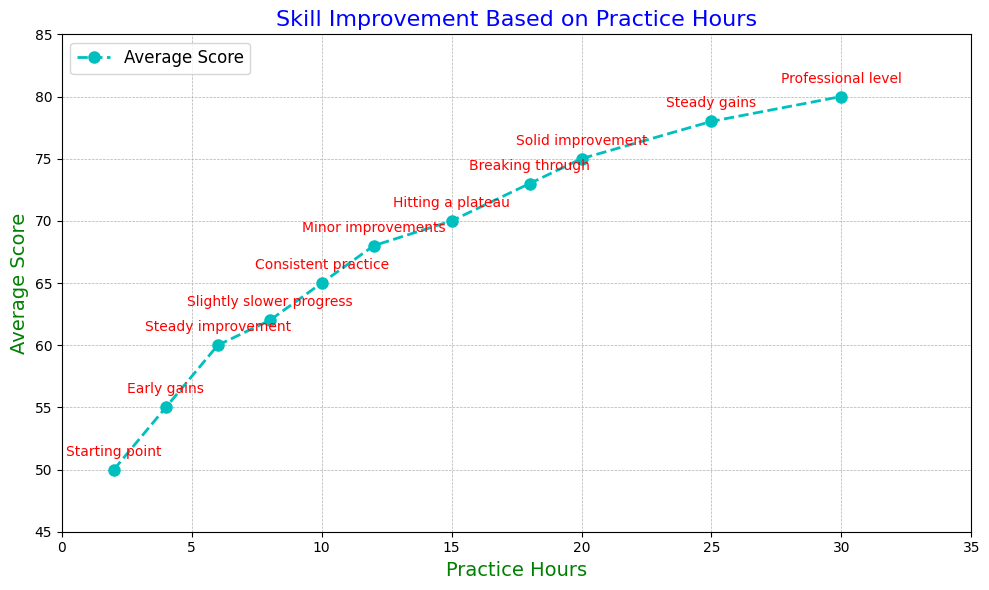What is the starting average score when the practice hours are 2? According to the annotation at the practice hour of 2, the average score is labeled as "Starting point" and the score is marked as 50.
Answer: 50 How many hours of practice does it take to reach the "Professional level"? The annotation "Professional level" is reached at 30 practice hours, as indicated by the label on the chart.
Answer: 30 Compare the average score at 8 practice hours to the score at 12 practice hours. Which is higher? From the plot, the average score at 8 hours is 62, and at 12 hours, it is 68. Therefore, the score at 12 practice hours is higher.
Answer: The score at 12 practice hours What is the average improvement in scores between 4 hours and 10 hours of practice? The scores improve from 55 at 4 hours to 65 at 10 hours, yielding an improvement of 65 - 55 = 10.
Answer: 10 At which point is there a “Hitting a plateau” in terms of practice hours, and what is the average score at that point? The annotation "Hitting a plateau" occurs at 15 practice hours, where the average score is 70.
Answer: At 15 practice hours, with an average score of 70 What’s the visual difference between scores at 18 and 25 practice hours in terms of average score increase? The annotation shows that the average score goes from 73 at 18 practice hours ("Breaking through") to 78 at 25 practice hours ("Steady gains"), an increase of 78 - 73 = 5.
Answer: The score increases by 5 Which annotation shows the most significant initial gain, and at what range of practice hours does this occur? The annotation "Early gains" between 2 and 4 practice hours shows the initial significant gain, where the score rises from 50 to 55.
Answer: "Early gains" between 2 and 4 hours What do the different colors of the labels for the axes denote? Both the x-axis and y-axis labels are green, indicating that the labels’ color is used for better readability and consistency.
Answer: Both axis labels are green What type of practice pattern is seen after consistent practice (10 hours), as indicated by the annotations? After consistent practice at 10 hours (“Consistent practice”), there is a marked slower but steady improvement in average scores as seen in the subsequent annotations.
Answer: Slower but steady improvements 